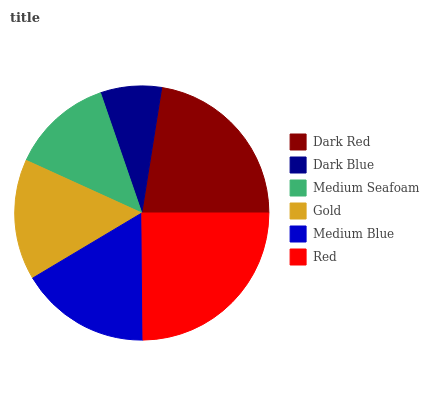Is Dark Blue the minimum?
Answer yes or no. Yes. Is Red the maximum?
Answer yes or no. Yes. Is Medium Seafoam the minimum?
Answer yes or no. No. Is Medium Seafoam the maximum?
Answer yes or no. No. Is Medium Seafoam greater than Dark Blue?
Answer yes or no. Yes. Is Dark Blue less than Medium Seafoam?
Answer yes or no. Yes. Is Dark Blue greater than Medium Seafoam?
Answer yes or no. No. Is Medium Seafoam less than Dark Blue?
Answer yes or no. No. Is Medium Blue the high median?
Answer yes or no. Yes. Is Gold the low median?
Answer yes or no. Yes. Is Gold the high median?
Answer yes or no. No. Is Medium Seafoam the low median?
Answer yes or no. No. 